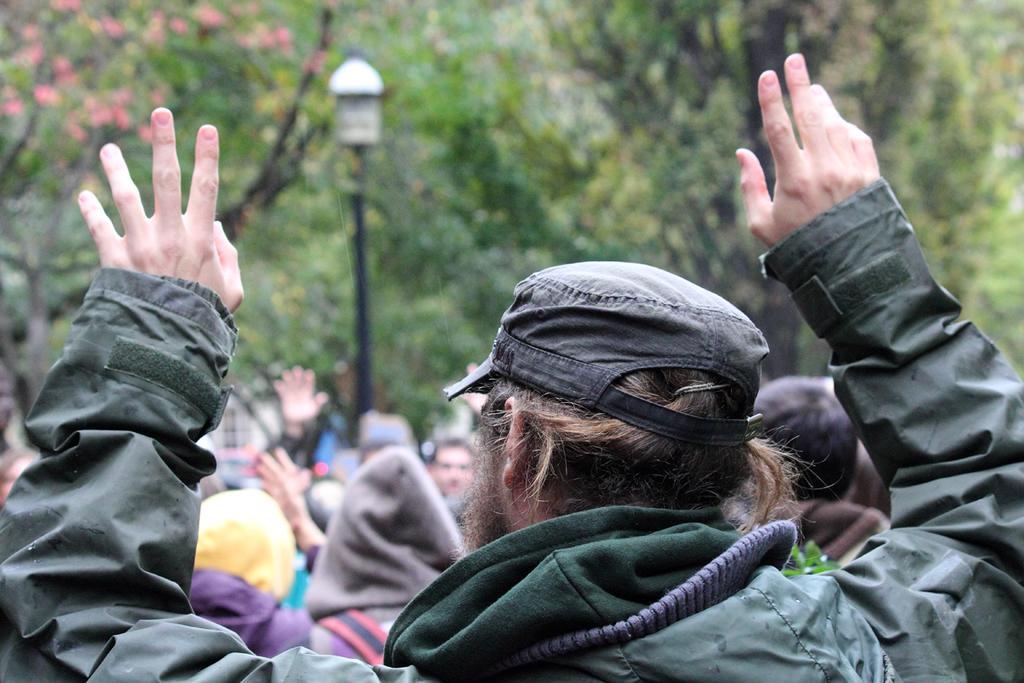Please provide a concise description of this image. In this image I can see few people. In front I can see a person wearing green jacket. I can see a light pole and trees. 